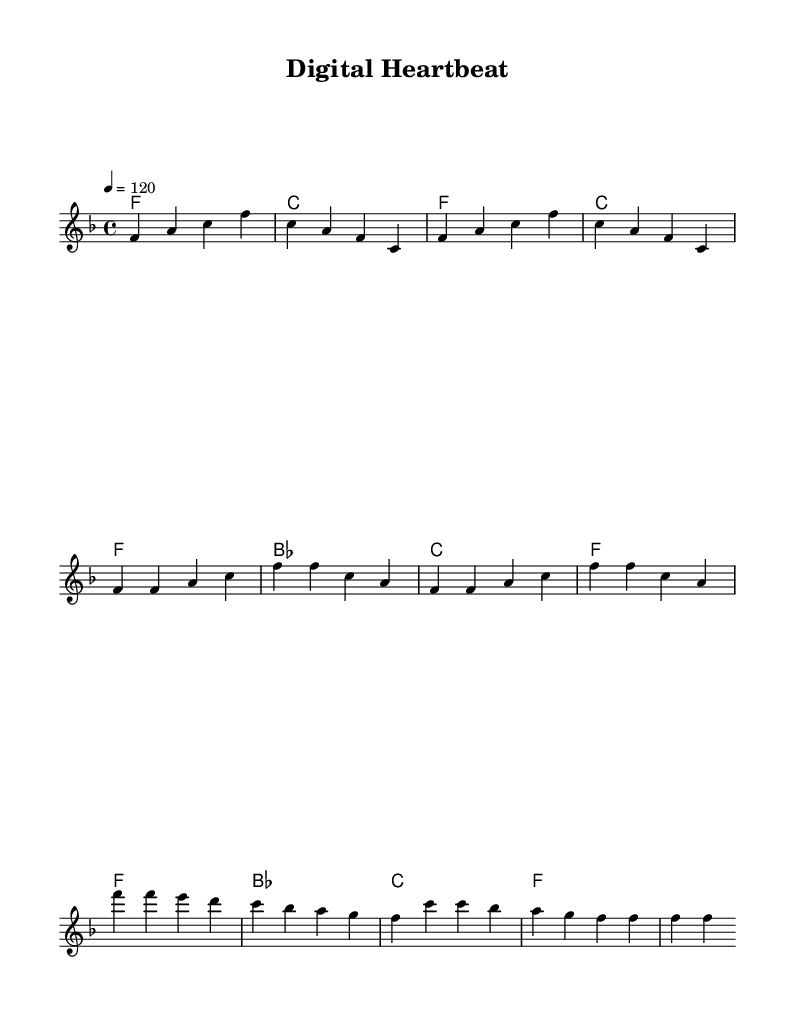What is the key signature of this music? The key signature is F major, which has one flat (B flat). You can identify the key signature at the beginning of the sheet music, where it indicates the sharps or flats.
Answer: F major What is the time signature of this music? The time signature is 4/4, which indicates that there are four beats per measure and the quarter note gets one beat. This can be seen at the beginning of the sheet music where the time signature is marked.
Answer: 4/4 What is the tempo of this piece? The tempo marking indicates a speed of quarter note equals 120 beats per minute. You can find this in the tempo instruction section of the sheet music.
Answer: 120 How many measures are in the introduction? The introduction consists of 4 measures, as indicated by the notation grouped at the beginning of the piece. We count the measures from the beginning until the end of the intro section.
Answer: 4 What is the highest note in the melody? The highest note in the melody is c'. Looking through the melody line, the note c' appears and is the highest pitch notated.
Answer: c' Which chord is played during the chorus? The chorus features the chords f, bes, and c. As per the chord changes indicated in the harmonies section, these chords support the melody during the chorus.
Answer: f, bes, c What emotional theme is expressed in the chorus? The chorus expresses a joyful and uplifting emotional theme, typical of upbeat soul music. This can be inferred from the rising melodic lines and the dynamic chord progression used, emphasizing a happy emotional tone.
Answer: Joyful 